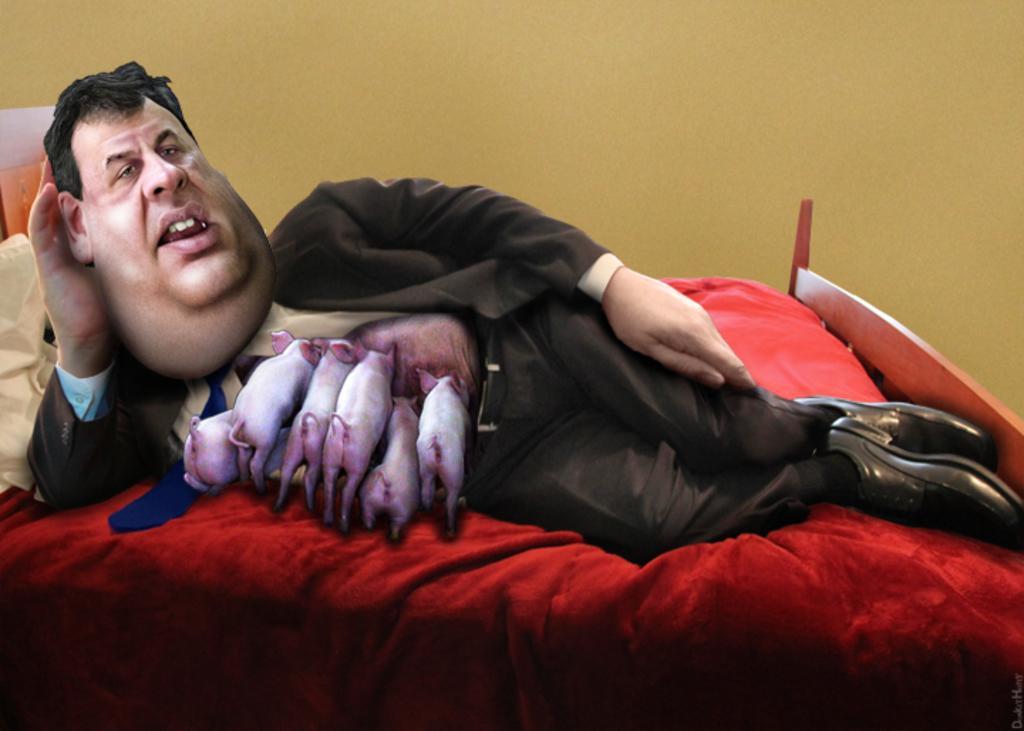Could you give a brief overview of what you see in this image? In this picture we can see cartoon. Here we can see man who is lying on the bed. On the back we can see wall. Here we can see bed sheet and pillows. 